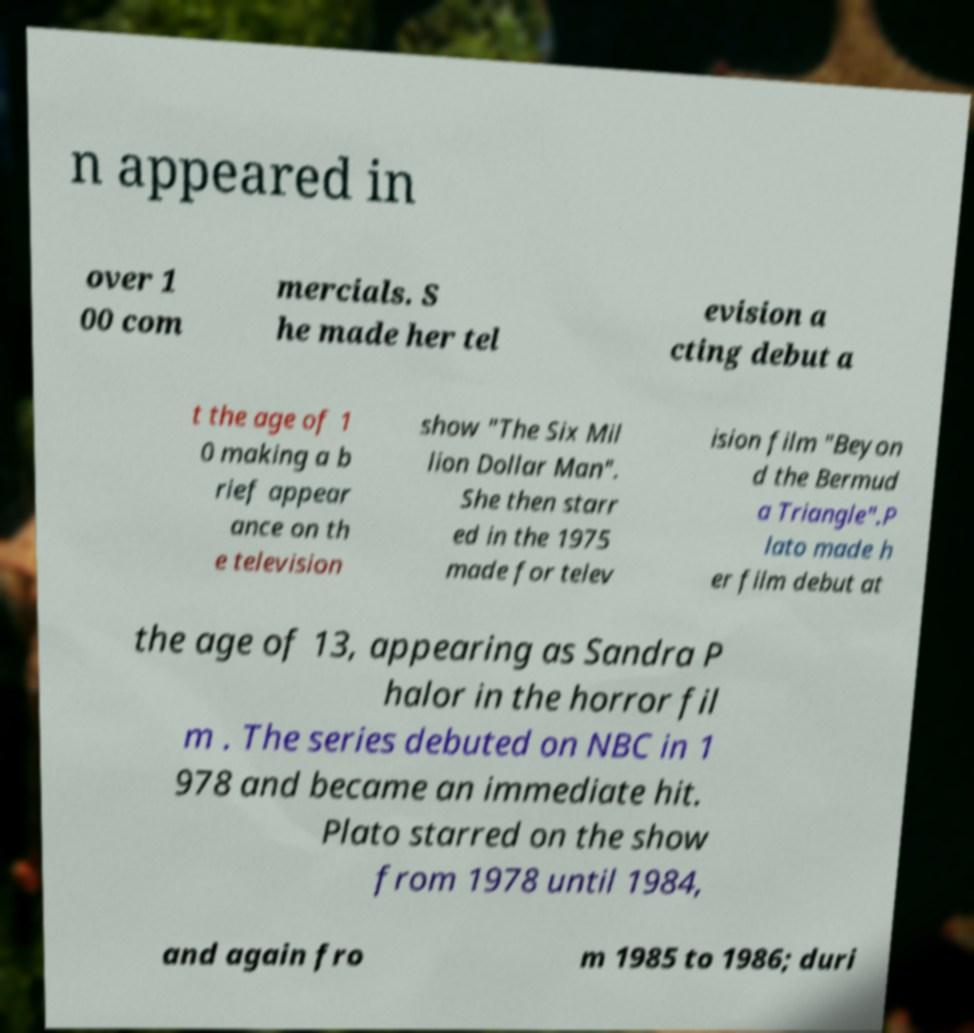There's text embedded in this image that I need extracted. Can you transcribe it verbatim? n appeared in over 1 00 com mercials. S he made her tel evision a cting debut a t the age of 1 0 making a b rief appear ance on th e television show "The Six Mil lion Dollar Man". She then starr ed in the 1975 made for telev ision film "Beyon d the Bermud a Triangle".P lato made h er film debut at the age of 13, appearing as Sandra P halor in the horror fil m . The series debuted on NBC in 1 978 and became an immediate hit. Plato starred on the show from 1978 until 1984, and again fro m 1985 to 1986; duri 